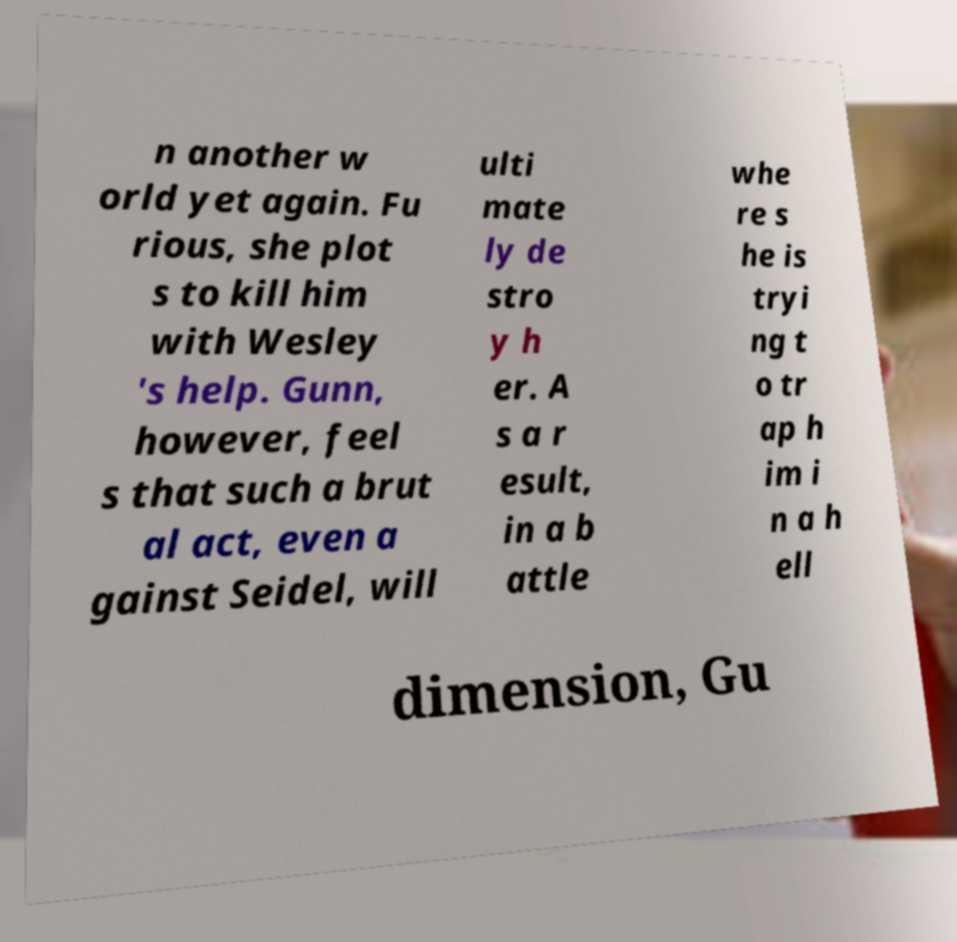Please read and relay the text visible in this image. What does it say? n another w orld yet again. Fu rious, she plot s to kill him with Wesley 's help. Gunn, however, feel s that such a brut al act, even a gainst Seidel, will ulti mate ly de stro y h er. A s a r esult, in a b attle whe re s he is tryi ng t o tr ap h im i n a h ell dimension, Gu 